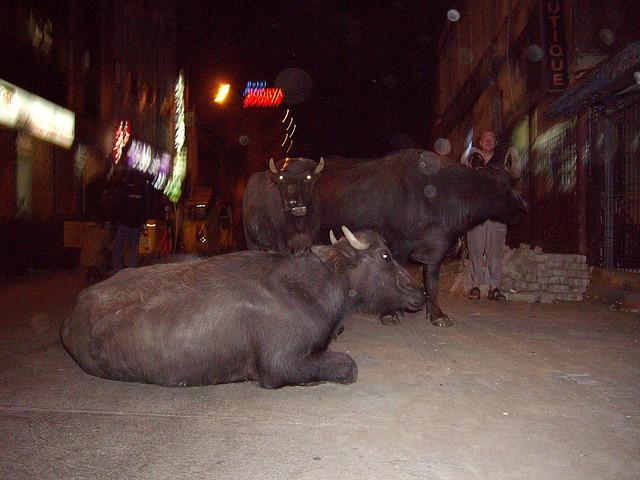Where is the animal currently sitting?

Choices:
A) street
B) park
C) boardwalk
D) beach street 